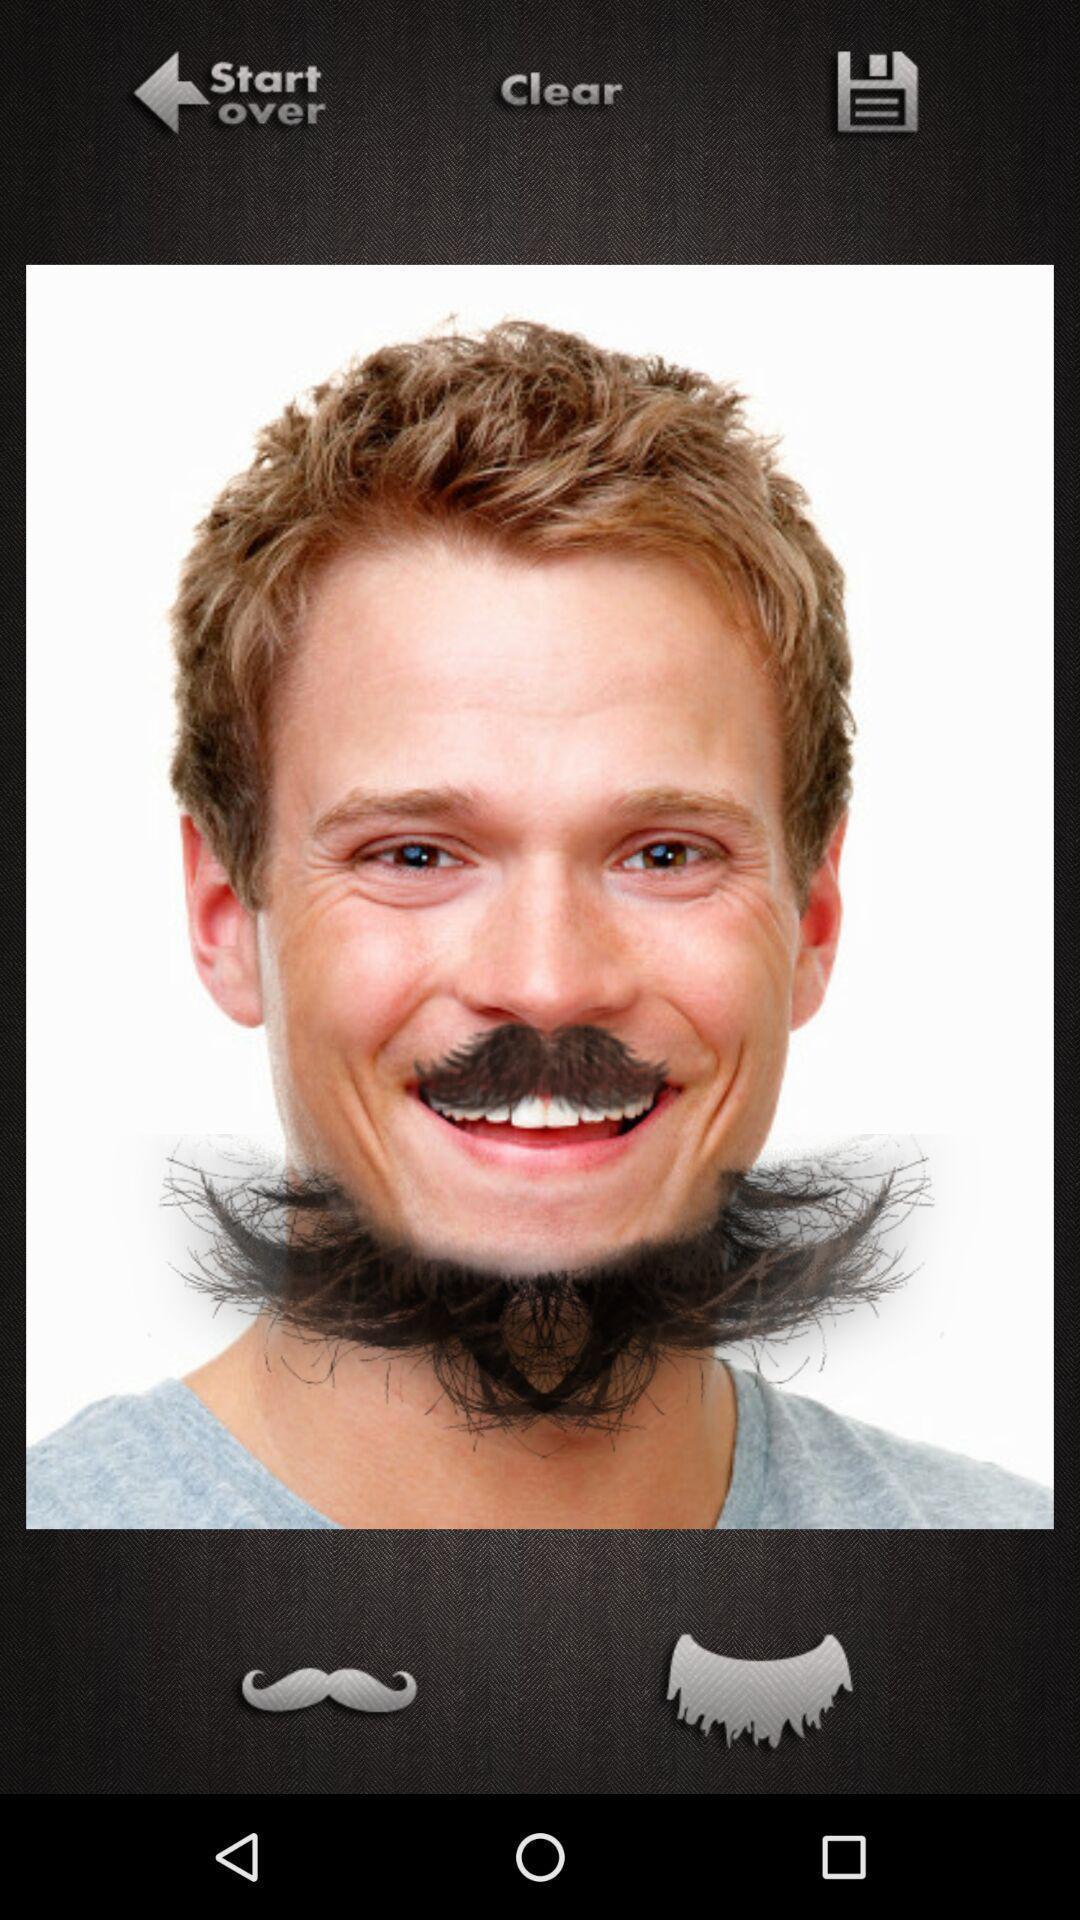What is the overall content of this screenshot? Screen displaying a image in editing app. 